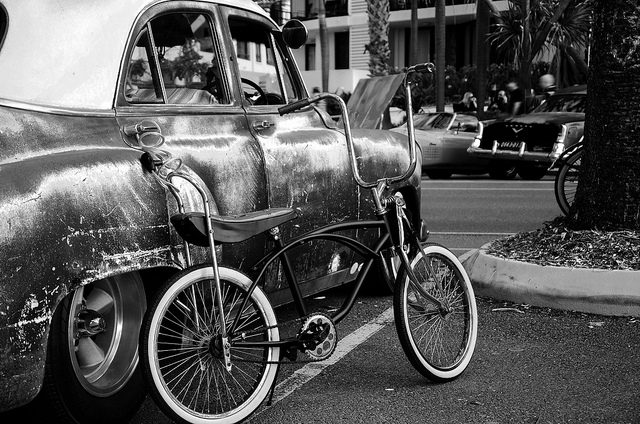How many bicycles are in the photo? There is a single bicycle visible in the photo, leaning against a vintage car with its chrome surface reflecting the surrounding environment. 